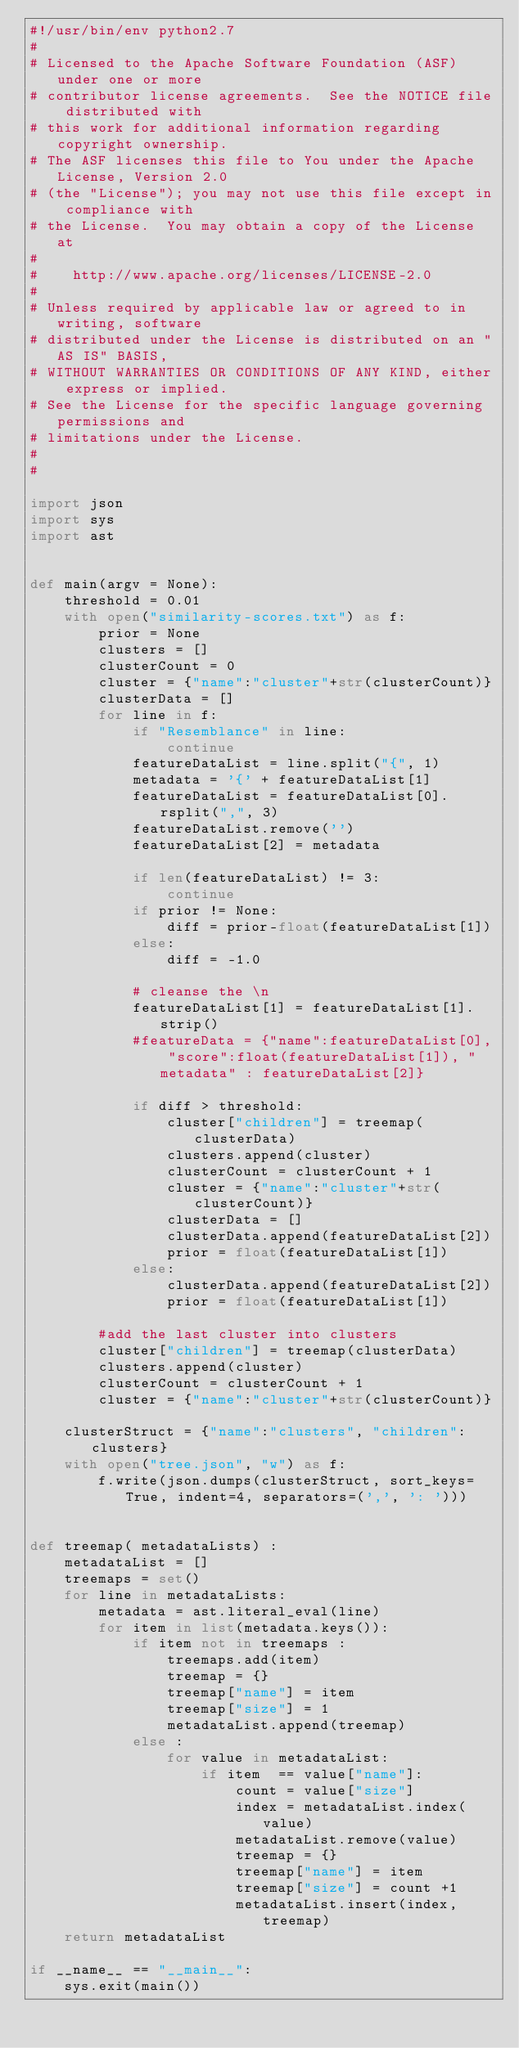Convert code to text. <code><loc_0><loc_0><loc_500><loc_500><_Python_>#!/usr/bin/env python2.7
#
# Licensed to the Apache Software Foundation (ASF) under one or more
# contributor license agreements.  See the NOTICE file distributed with
# this work for additional information regarding copyright ownership.
# The ASF licenses this file to You under the Apache License, Version 2.0
# (the "License"); you may not use this file except in compliance with
# the License.  You may obtain a copy of the License at
#
#    http://www.apache.org/licenses/LICENSE-2.0
#
# Unless required by applicable law or agreed to in writing, software
# distributed under the License is distributed on an "AS IS" BASIS,
# WITHOUT WARRANTIES OR CONDITIONS OF ANY KIND, either express or implied.
# See the License for the specific language governing permissions and
# limitations under the License.
#
#

import json
import sys
import ast


def main(argv = None):
    threshold = 0.01
    with open("similarity-scores.txt") as f:
        prior = None
        clusters = []
        clusterCount = 0
        cluster = {"name":"cluster"+str(clusterCount)}
        clusterData = []
        for line in f:
            if "Resemblance" in line:
                continue
            featureDataList = line.split("{", 1)
            metadata = '{' + featureDataList[1]
            featureDataList = featureDataList[0].rsplit(",", 3)
            featureDataList.remove('')
            featureDataList[2] = metadata

            if len(featureDataList) != 3:
                continue
            if prior != None:
                diff = prior-float(featureDataList[1])
            else:
                diff = -1.0

            # cleanse the \n
            featureDataList[1] = featureDataList[1].strip()
            #featureData = {"name":featureDataList[0], "score":float(featureDataList[1]), "metadata" : featureDataList[2]}

            if diff > threshold:
                cluster["children"] = treemap(clusterData)
                clusters.append(cluster)
                clusterCount = clusterCount + 1
                cluster = {"name":"cluster"+str(clusterCount)}
                clusterData = []
                clusterData.append(featureDataList[2])
                prior = float(featureDataList[1])
            else:
                clusterData.append(featureDataList[2])
                prior = float(featureDataList[1])

        #add the last cluster into clusters
        cluster["children"] = treemap(clusterData)
        clusters.append(cluster)
        clusterCount = clusterCount + 1
        cluster = {"name":"cluster"+str(clusterCount)}

    clusterStruct = {"name":"clusters", "children":clusters}
    with open("tree.json", "w") as f:
        f.write(json.dumps(clusterStruct, sort_keys=True, indent=4, separators=(',', ': ')))


def treemap( metadataLists) :
    metadataList = []
    treemaps = set()
    for line in metadataLists:
        metadata = ast.literal_eval(line)
        for item in list(metadata.keys()):
            if item not in treemaps :
                treemaps.add(item)
                treemap = {}
                treemap["name"] = item
                treemap["size"] = 1
                metadataList.append(treemap)
            else :
                for value in metadataList:
                    if item  == value["name"]:
                        count = value["size"]
                        index = metadataList.index(value)
                        metadataList.remove(value)
                        treemap = {}
                        treemap["name"] = item
                        treemap["size"] = count +1
                        metadataList.insert(index, treemap)
    return metadataList

if __name__ == "__main__":
    sys.exit(main())


</code> 